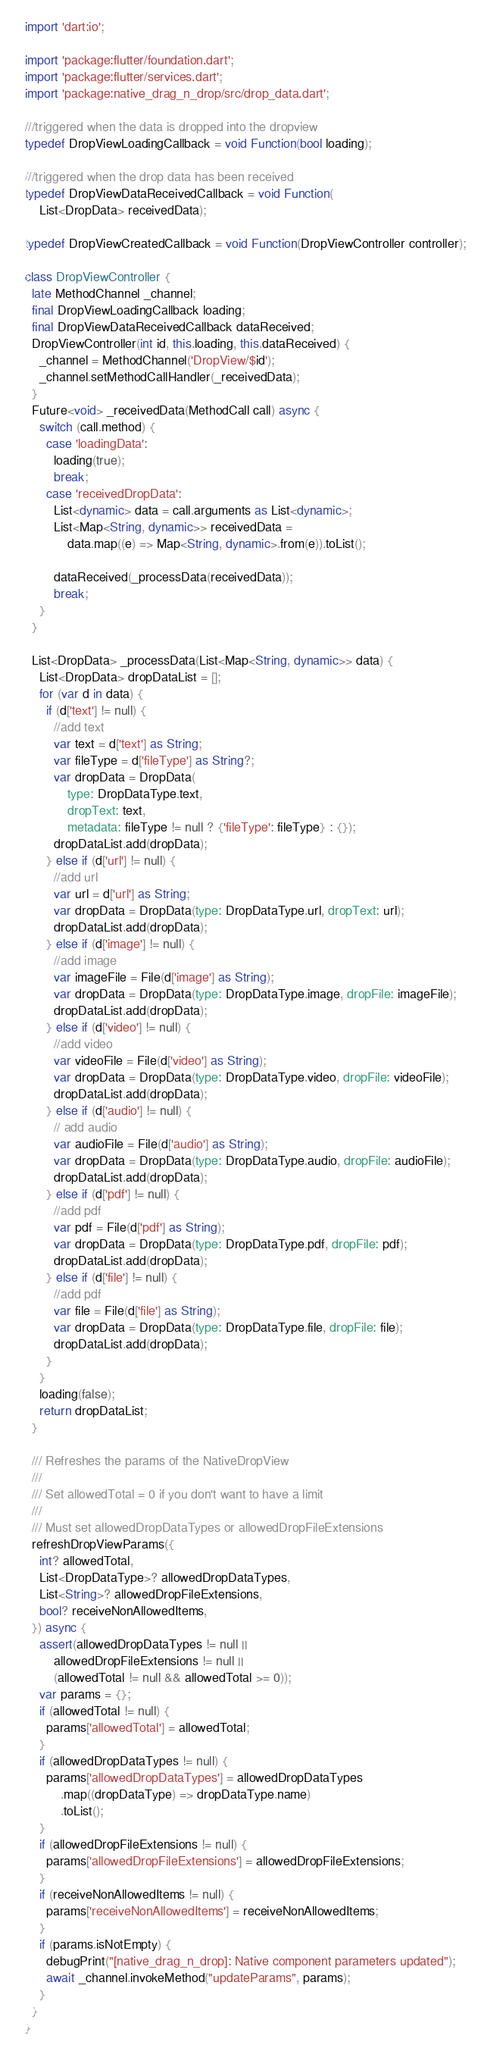Convert code to text. <code><loc_0><loc_0><loc_500><loc_500><_Dart_>import 'dart:io';

import 'package:flutter/foundation.dart';
import 'package:flutter/services.dart';
import 'package:native_drag_n_drop/src/drop_data.dart';

///triggered when the data is dropped into the dropview
typedef DropViewLoadingCallback = void Function(bool loading);

///triggered when the drop data has been received
typedef DropViewDataReceivedCallback = void Function(
    List<DropData> receivedData);

typedef DropViewCreatedCallback = void Function(DropViewController controller);

class DropViewController {
  late MethodChannel _channel;
  final DropViewLoadingCallback loading;
  final DropViewDataReceivedCallback dataReceived;
  DropViewController(int id, this.loading, this.dataReceived) {
    _channel = MethodChannel('DropView/$id');
    _channel.setMethodCallHandler(_receivedData);
  }
  Future<void> _receivedData(MethodCall call) async {
    switch (call.method) {
      case 'loadingData':
        loading(true);
        break;
      case 'receivedDropData':
        List<dynamic> data = call.arguments as List<dynamic>;
        List<Map<String, dynamic>> receivedData =
            data.map((e) => Map<String, dynamic>.from(e)).toList();

        dataReceived(_processData(receivedData));
        break;
    }
  }

  List<DropData> _processData(List<Map<String, dynamic>> data) {
    List<DropData> dropDataList = [];
    for (var d in data) {
      if (d['text'] != null) {
        //add text
        var text = d['text'] as String;
        var fileType = d['fileType'] as String?;
        var dropData = DropData(
            type: DropDataType.text,
            dropText: text,
            metadata: fileType != null ? {'fileType': fileType} : {});
        dropDataList.add(dropData);
      } else if (d['url'] != null) {
        //add url
        var url = d['url'] as String;
        var dropData = DropData(type: DropDataType.url, dropText: url);
        dropDataList.add(dropData);
      } else if (d['image'] != null) {
        //add image
        var imageFile = File(d['image'] as String);
        var dropData = DropData(type: DropDataType.image, dropFile: imageFile);
        dropDataList.add(dropData);
      } else if (d['video'] != null) {
        //add video
        var videoFile = File(d['video'] as String);
        var dropData = DropData(type: DropDataType.video, dropFile: videoFile);
        dropDataList.add(dropData);
      } else if (d['audio'] != null) {
        // add audio
        var audioFile = File(d['audio'] as String);
        var dropData = DropData(type: DropDataType.audio, dropFile: audioFile);
        dropDataList.add(dropData);
      } else if (d['pdf'] != null) {
        //add pdf
        var pdf = File(d['pdf'] as String);
        var dropData = DropData(type: DropDataType.pdf, dropFile: pdf);
        dropDataList.add(dropData);
      } else if (d['file'] != null) {
        //add pdf
        var file = File(d['file'] as String);
        var dropData = DropData(type: DropDataType.file, dropFile: file);
        dropDataList.add(dropData);
      }
    }
    loading(false);
    return dropDataList;
  }

  /// Refreshes the params of the NativeDropView
  ///
  /// Set allowedTotal = 0 if you don't want to have a limit
  ///
  /// Must set allowedDropDataTypes or allowedDropFileExtensions
  refreshDropViewParams({
    int? allowedTotal,
    List<DropDataType>? allowedDropDataTypes,
    List<String>? allowedDropFileExtensions,
    bool? receiveNonAllowedItems,
  }) async {
    assert(allowedDropDataTypes != null ||
        allowedDropFileExtensions != null ||
        (allowedTotal != null && allowedTotal >= 0));
    var params = {};
    if (allowedTotal != null) {
      params['allowedTotal'] = allowedTotal;
    }
    if (allowedDropDataTypes != null) {
      params['allowedDropDataTypes'] = allowedDropDataTypes
          .map((dropDataType) => dropDataType.name)
          .toList();
    }
    if (allowedDropFileExtensions != null) {
      params['allowedDropFileExtensions'] = allowedDropFileExtensions;
    }
    if (receiveNonAllowedItems != null) {
      params['receiveNonAllowedItems'] = receiveNonAllowedItems;
    }
    if (params.isNotEmpty) {
      debugPrint("[native_drag_n_drop]: Native component parameters updated");
      await _channel.invokeMethod("updateParams", params);
    }
  }
}
</code> 